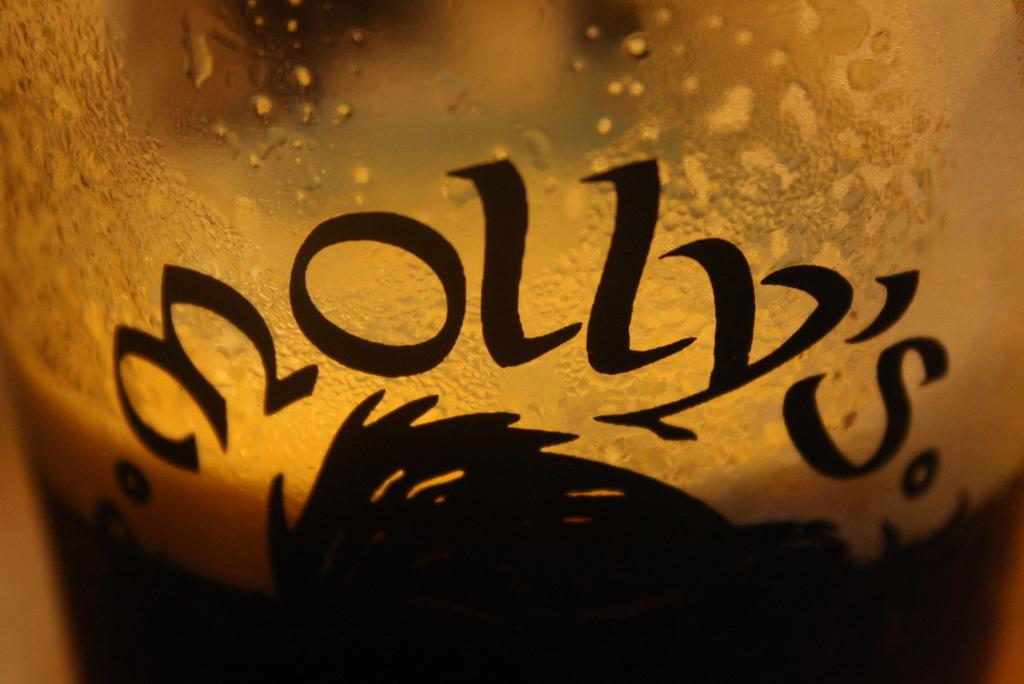<image>
Create a compact narrative representing the image presented. a close up of a half full glass beer reading MOLLY's 